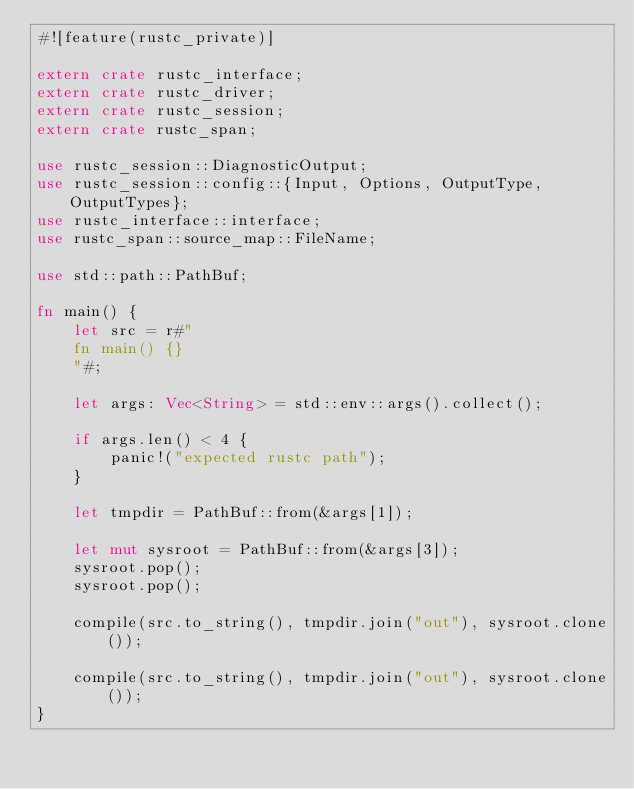<code> <loc_0><loc_0><loc_500><loc_500><_Rust_>#![feature(rustc_private)]

extern crate rustc_interface;
extern crate rustc_driver;
extern crate rustc_session;
extern crate rustc_span;

use rustc_session::DiagnosticOutput;
use rustc_session::config::{Input, Options, OutputType, OutputTypes};
use rustc_interface::interface;
use rustc_span::source_map::FileName;

use std::path::PathBuf;

fn main() {
    let src = r#"
    fn main() {}
    "#;

    let args: Vec<String> = std::env::args().collect();

    if args.len() < 4 {
        panic!("expected rustc path");
    }

    let tmpdir = PathBuf::from(&args[1]);

    let mut sysroot = PathBuf::from(&args[3]);
    sysroot.pop();
    sysroot.pop();

    compile(src.to_string(), tmpdir.join("out"), sysroot.clone());

    compile(src.to_string(), tmpdir.join("out"), sysroot.clone());
}
</code> 